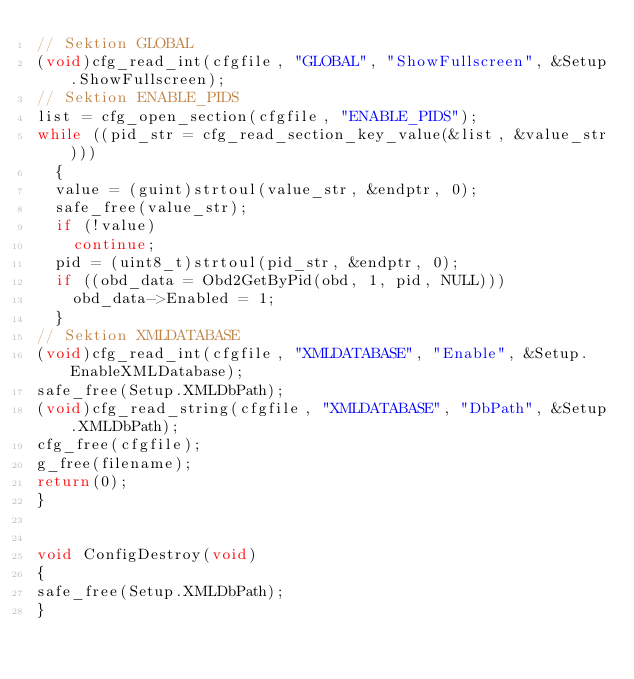<code> <loc_0><loc_0><loc_500><loc_500><_C_>// Sektion GLOBAL
(void)cfg_read_int(cfgfile, "GLOBAL", "ShowFullscreen", &Setup.ShowFullscreen);
// Sektion ENABLE_PIDS
list = cfg_open_section(cfgfile, "ENABLE_PIDS");
while ((pid_str = cfg_read_section_key_value(&list, &value_str)))
  {
  value = (guint)strtoul(value_str, &endptr, 0);  
  safe_free(value_str);
  if (!value)
    continue; 
  pid = (uint8_t)strtoul(pid_str, &endptr, 0);
  if ((obd_data = Obd2GetByPid(obd, 1, pid, NULL)))    
    obd_data->Enabled = 1;  
  }
// Sektion XMLDATABASE
(void)cfg_read_int(cfgfile, "XMLDATABASE", "Enable", &Setup.EnableXMLDatabase);
safe_free(Setup.XMLDbPath);
(void)cfg_read_string(cfgfile, "XMLDATABASE", "DbPath", &Setup.XMLDbPath);
cfg_free(cfgfile);
g_free(filename);
return(0);
}


void ConfigDestroy(void)
{
safe_free(Setup.XMLDbPath);
}





</code> 